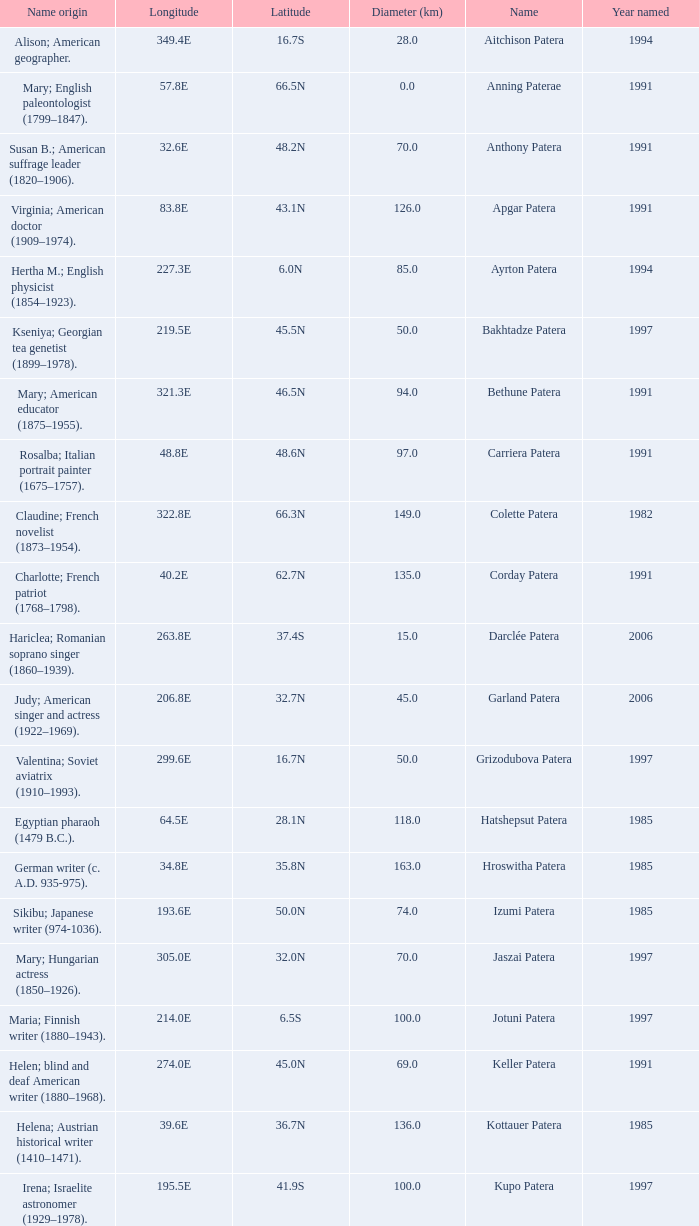In what year was the feature at a 33.3S latitude named?  2000.0. 